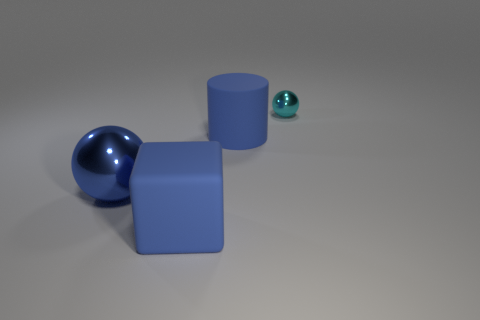What number of big blue rubber cubes are on the right side of the big blue matte block?
Offer a very short reply. 0. Does the large blue object behind the big blue sphere have the same material as the tiny cyan object?
Your answer should be very brief. No. How many other things have the same shape as the large metallic object?
Your answer should be compact. 1. How many large things are either blue shiny blocks or rubber blocks?
Keep it short and to the point. 1. There is a object that is to the right of the blue cylinder; does it have the same color as the big ball?
Offer a very short reply. No. There is a metal ball behind the blue sphere; is its color the same as the rubber object on the left side of the big blue rubber cylinder?
Your response must be concise. No. Are there any big objects made of the same material as the big cube?
Provide a succinct answer. Yes. How many gray objects are big metal cubes or large shiny spheres?
Ensure brevity in your answer.  0. Are there more small cyan spheres in front of the blue matte block than large red matte cylinders?
Offer a terse response. No. Do the cyan thing and the blue metallic sphere have the same size?
Ensure brevity in your answer.  No. 